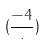<formula> <loc_0><loc_0><loc_500><loc_500>( \frac { - 4 } { \cdot } )</formula> 